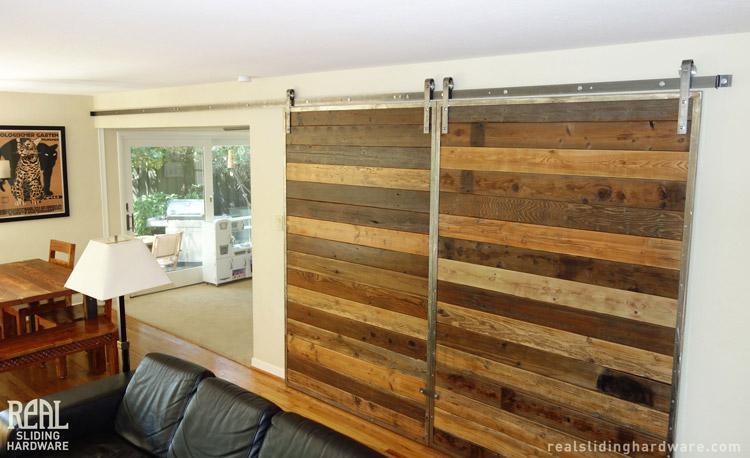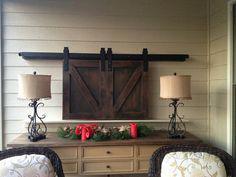The first image is the image on the left, the second image is the image on the right. Examine the images to the left and right. Is the description "A sliding television cabinet is open." accurate? Answer yes or no. No. The first image is the image on the left, the second image is the image on the right. Considering the images on both sides, is "An image shows 'barn doors' that slide on a black bar overhead, above a wide dresser with lamps on each end." valid? Answer yes or no. Yes. 